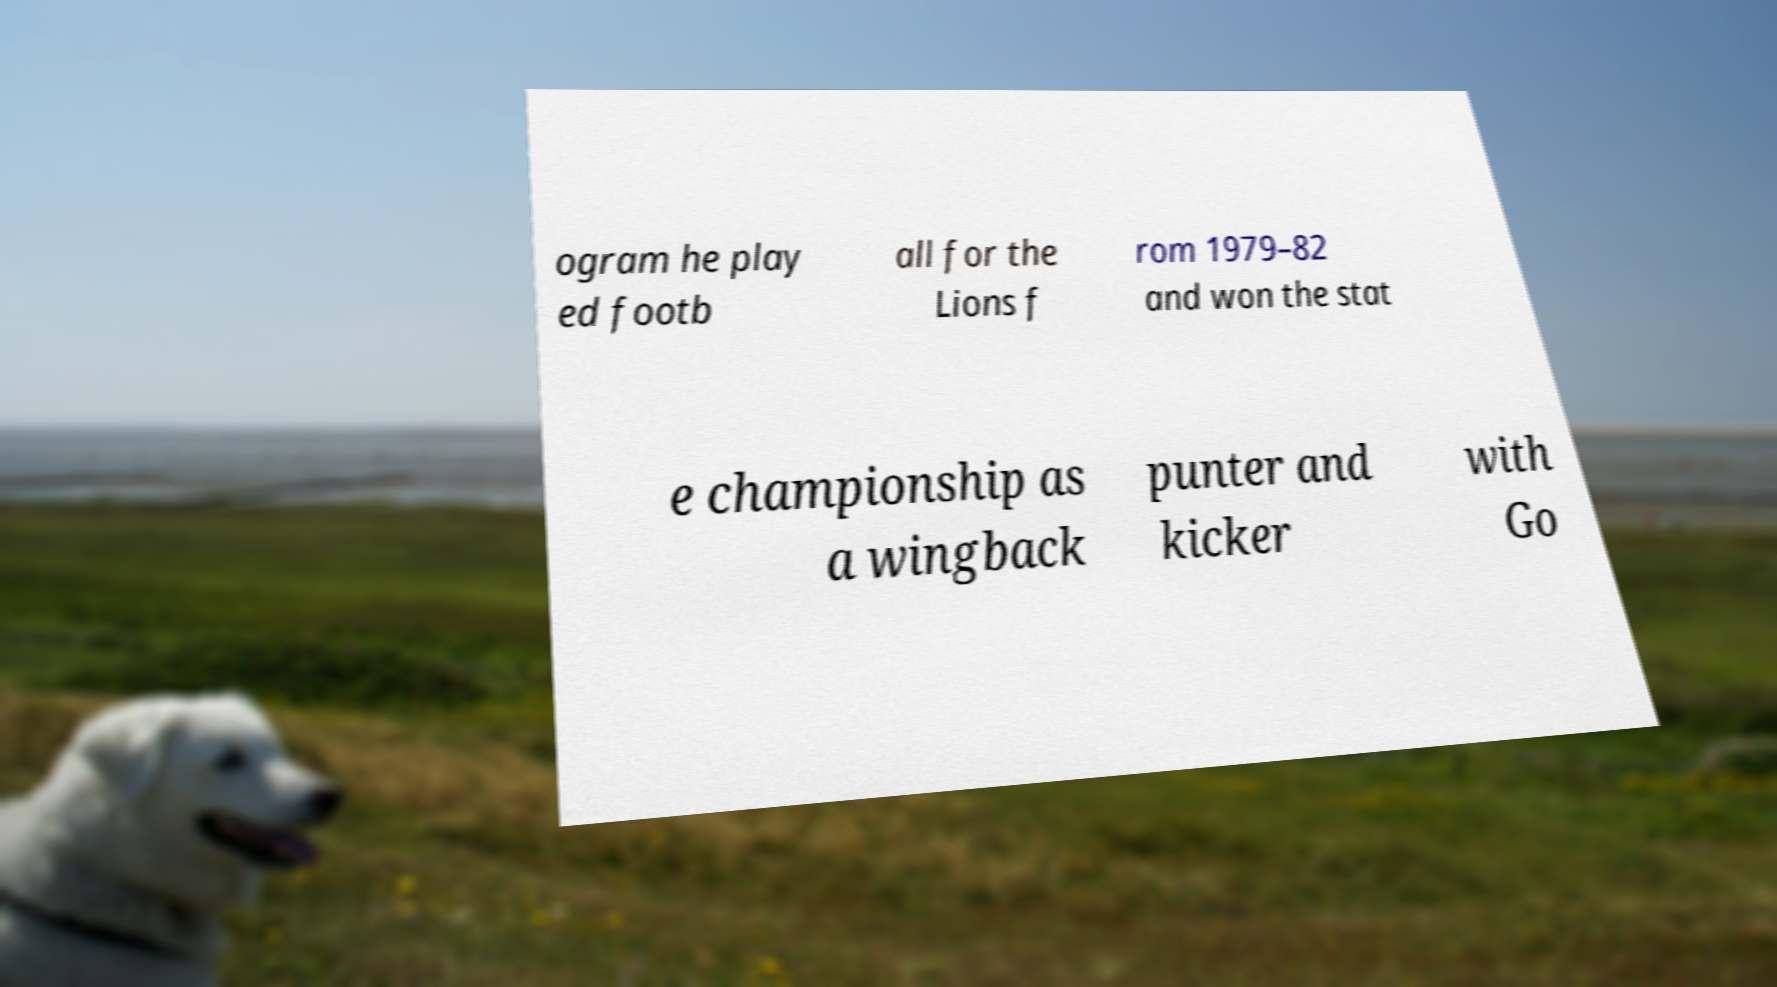What messages or text are displayed in this image? I need them in a readable, typed format. ogram he play ed footb all for the Lions f rom 1979–82 and won the stat e championship as a wingback punter and kicker with Go 